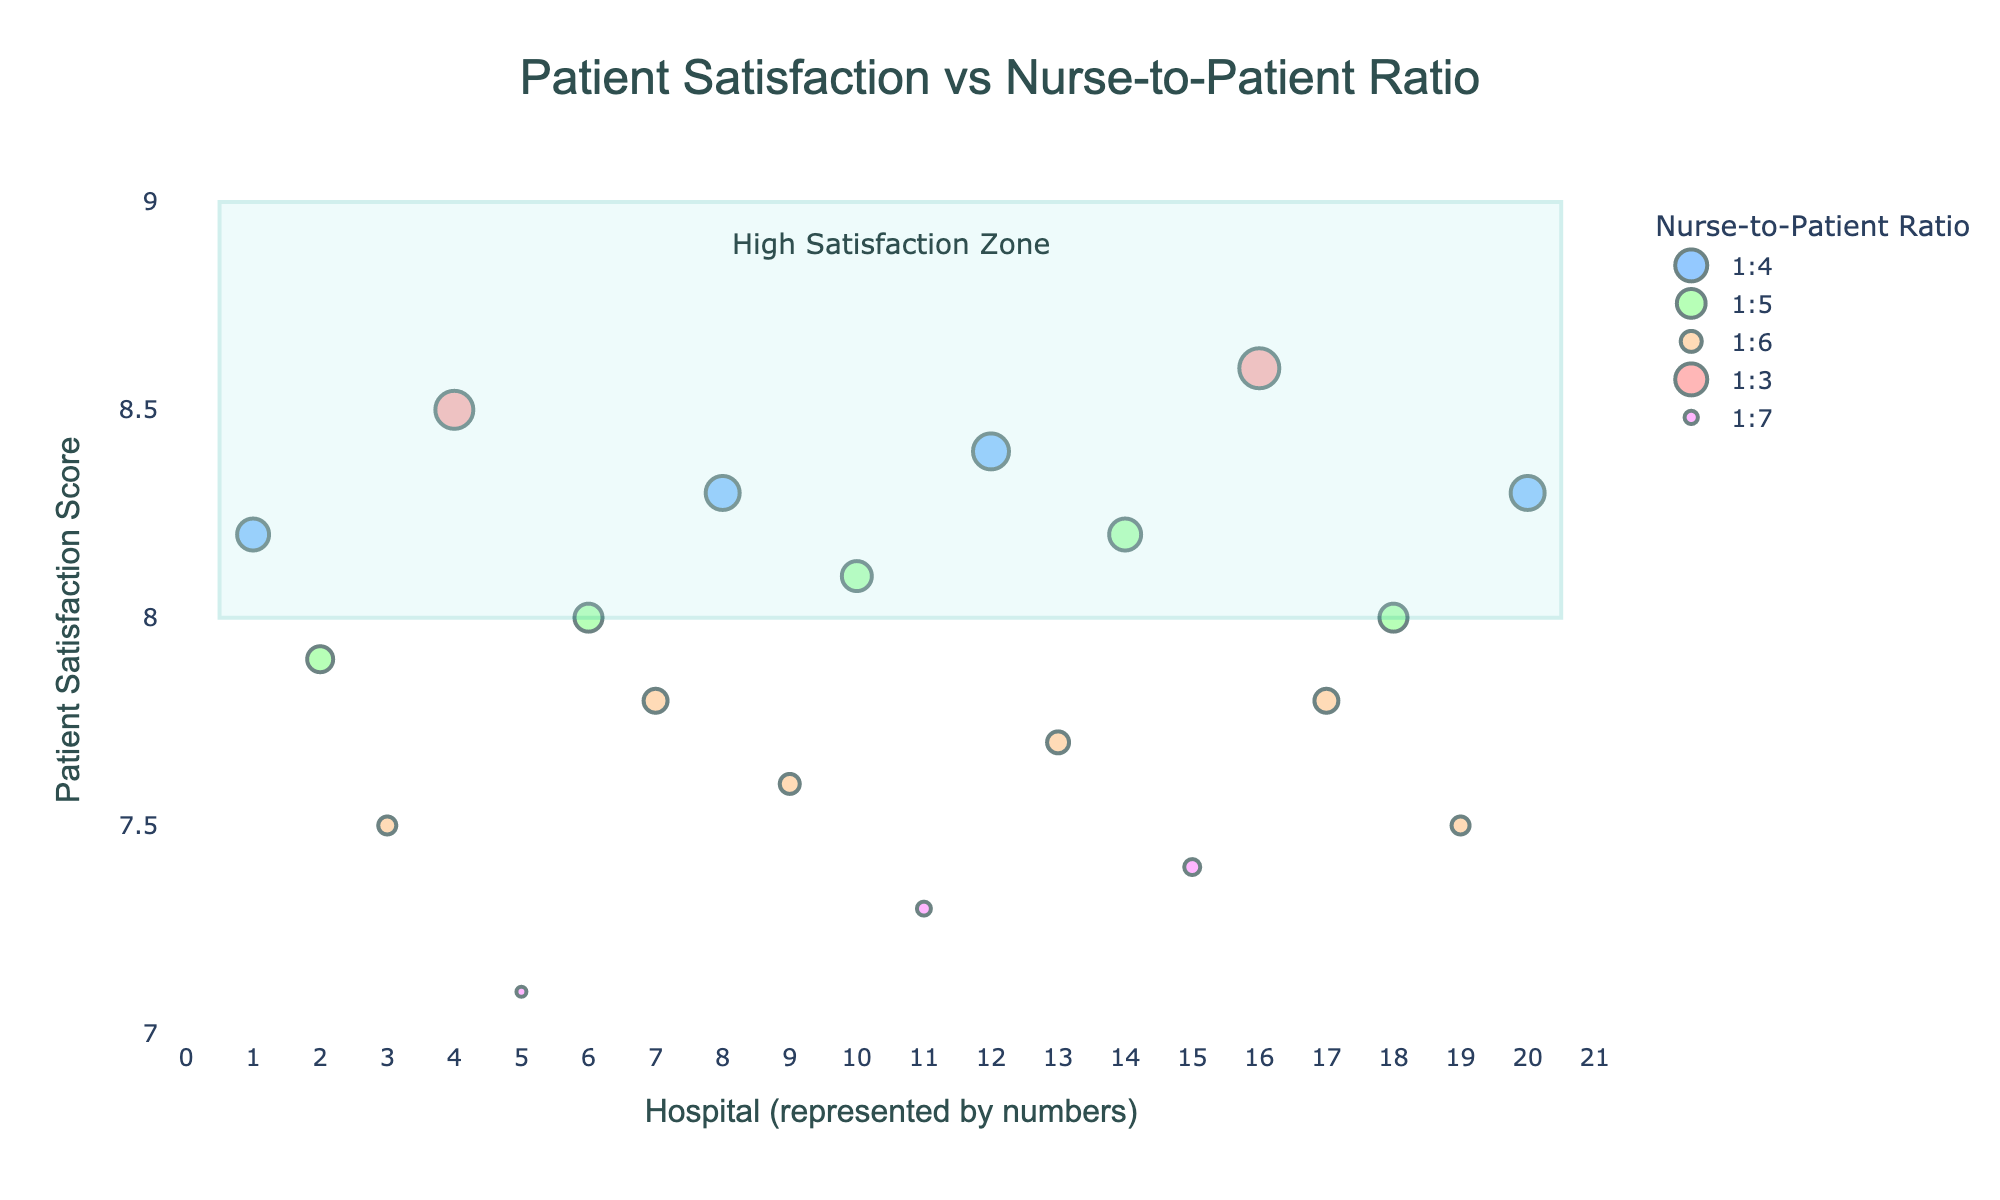What's the title of the plot? The title is typically placed at the top center of the plot. In this case, it displays the overall theme of the data visualization.
Answer: "Patient Satisfaction vs Nurse-to-Patient Ratio" What is the highest patient satisfaction score shown on the graph? Look at the y-axis to find the highest value, and identify the point that reaches this value.
Answer: 8.6 Which ratio category has the lowest patient satisfaction score and what is that score? By examining the plotted points, locate the lowest y-value and identify the associated ratio. The lowest visible point is associated with the ratio '1:7' which is the color purple and corresponds to the lowest position on the y-axis.
Answer: 1:7, 7.1 How many hospitals fall into the "High Satisfaction Zone"? Identify the rectangular overlay indicating the "High Satisfaction Zone". Count the points (hospitals) that lie within the boundaries of this region, which is between y=8.0 and y=9.0 on the y-axis.
Answer: 7 Which hospital has a nurse-to-patient ratio of 1:3 and the highest satisfaction score? Locate the points categorized by the ratio of 1:3 (red dots) and find the one with the highest y-value. By hovering over these points in an interactive graph, it reveals the hospital’s name.
Answer: Houston Methodist Hospital Comparing hospitals with a nurse-to-patient ratio of 1:4, which hospital has the highest satisfaction score? Identify the points with a 1:4 ratio (blue dots) on the plot, then locate the one with the highest y-value. Check the associated hospital name by provided hover information.
Answer: Houston Methodist Hospital How does the satisfaction score for Johns Hopkins Hospital compare with Massachusetts General Hospital? Identify the points for both hospitals. Johns Hopkins Hospital has a lower satisfaction score (7.5) compared to Massachusetts General Hospital (8.5), respective points can be checked by their y-values.
Answer: Johns Hopkins Hospital has a lower score than Massachusetts General Hospital How many hospitals have a patient satisfaction score of at least 8.0? Count the data points that lie at or above the y-axis value of 8.0, and determine the total number of such hospitals.
Answer: 9 Which nurse-to-patient ratio appears to have the most hospitals falling into the high satisfaction range (above 8.0)? Examine each ratio’s data points and count how many of them exceed the y-value of 8.0. The ratio 1:4 (blue dots) appears to have the most hospitals in this range.
Answer: 1:4 What’s the average satisfaction score among hospitals with a nurse-to-patient ratio of 1:6? Sum the satisfaction scores for hospitals with a 1:6 ratio and divide by the number of these hospitals. Scores: 7.5, 7.8, 7.7, 7.8, 7.5. Average = (7.5 + 7.8 + 7.7 + 7.8 + 7.5) / 5 = 7.66.
Answer: 7.66 